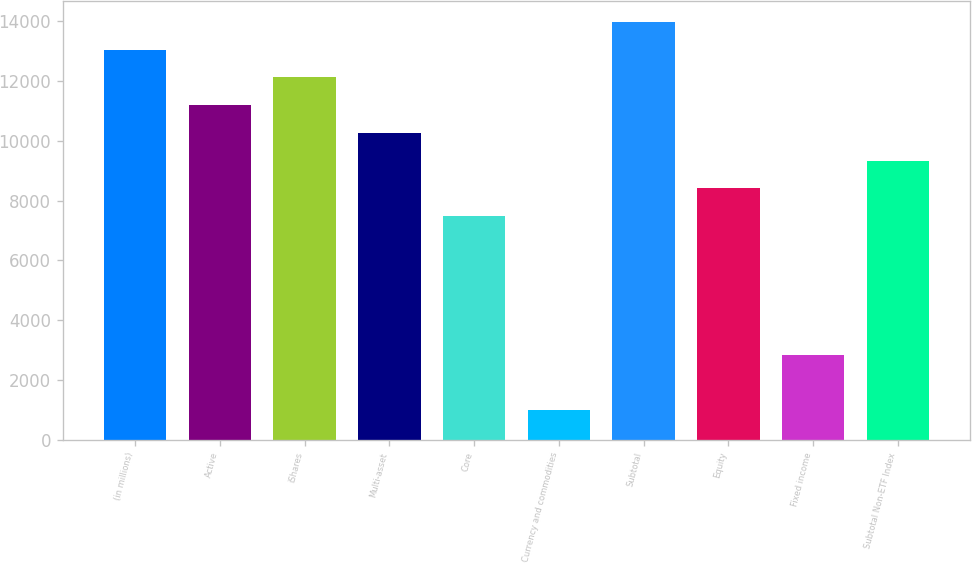Convert chart. <chart><loc_0><loc_0><loc_500><loc_500><bar_chart><fcel>(in millions)<fcel>Active<fcel>iShares<fcel>Multi-asset<fcel>Core<fcel>Currency and commodities<fcel>Subtotal<fcel>Equity<fcel>Fixed income<fcel>Subtotal Non-ETF Index<nl><fcel>13043.4<fcel>11190.2<fcel>12116.8<fcel>10263.6<fcel>7483.8<fcel>997.6<fcel>13970<fcel>8410.4<fcel>2850.8<fcel>9337<nl></chart> 